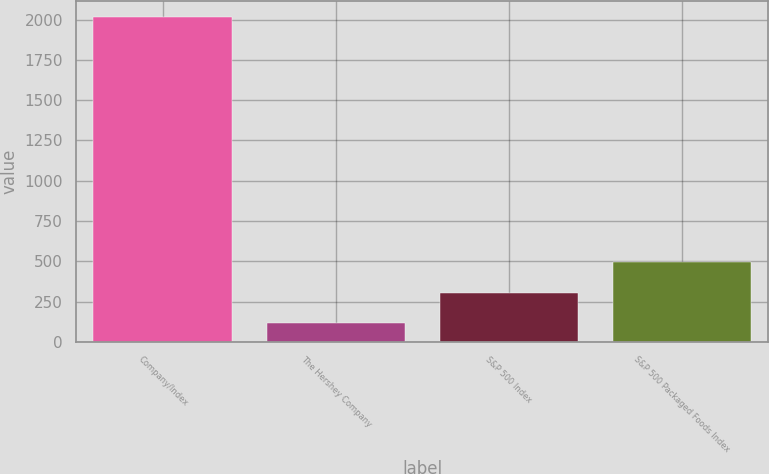Convert chart to OTSL. <chart><loc_0><loc_0><loc_500><loc_500><bar_chart><fcel>Company/Index<fcel>The Hershey Company<fcel>S&P 500 Index<fcel>S&P 500 Packaged Foods Index<nl><fcel>2016<fcel>114<fcel>304.2<fcel>494.4<nl></chart> 